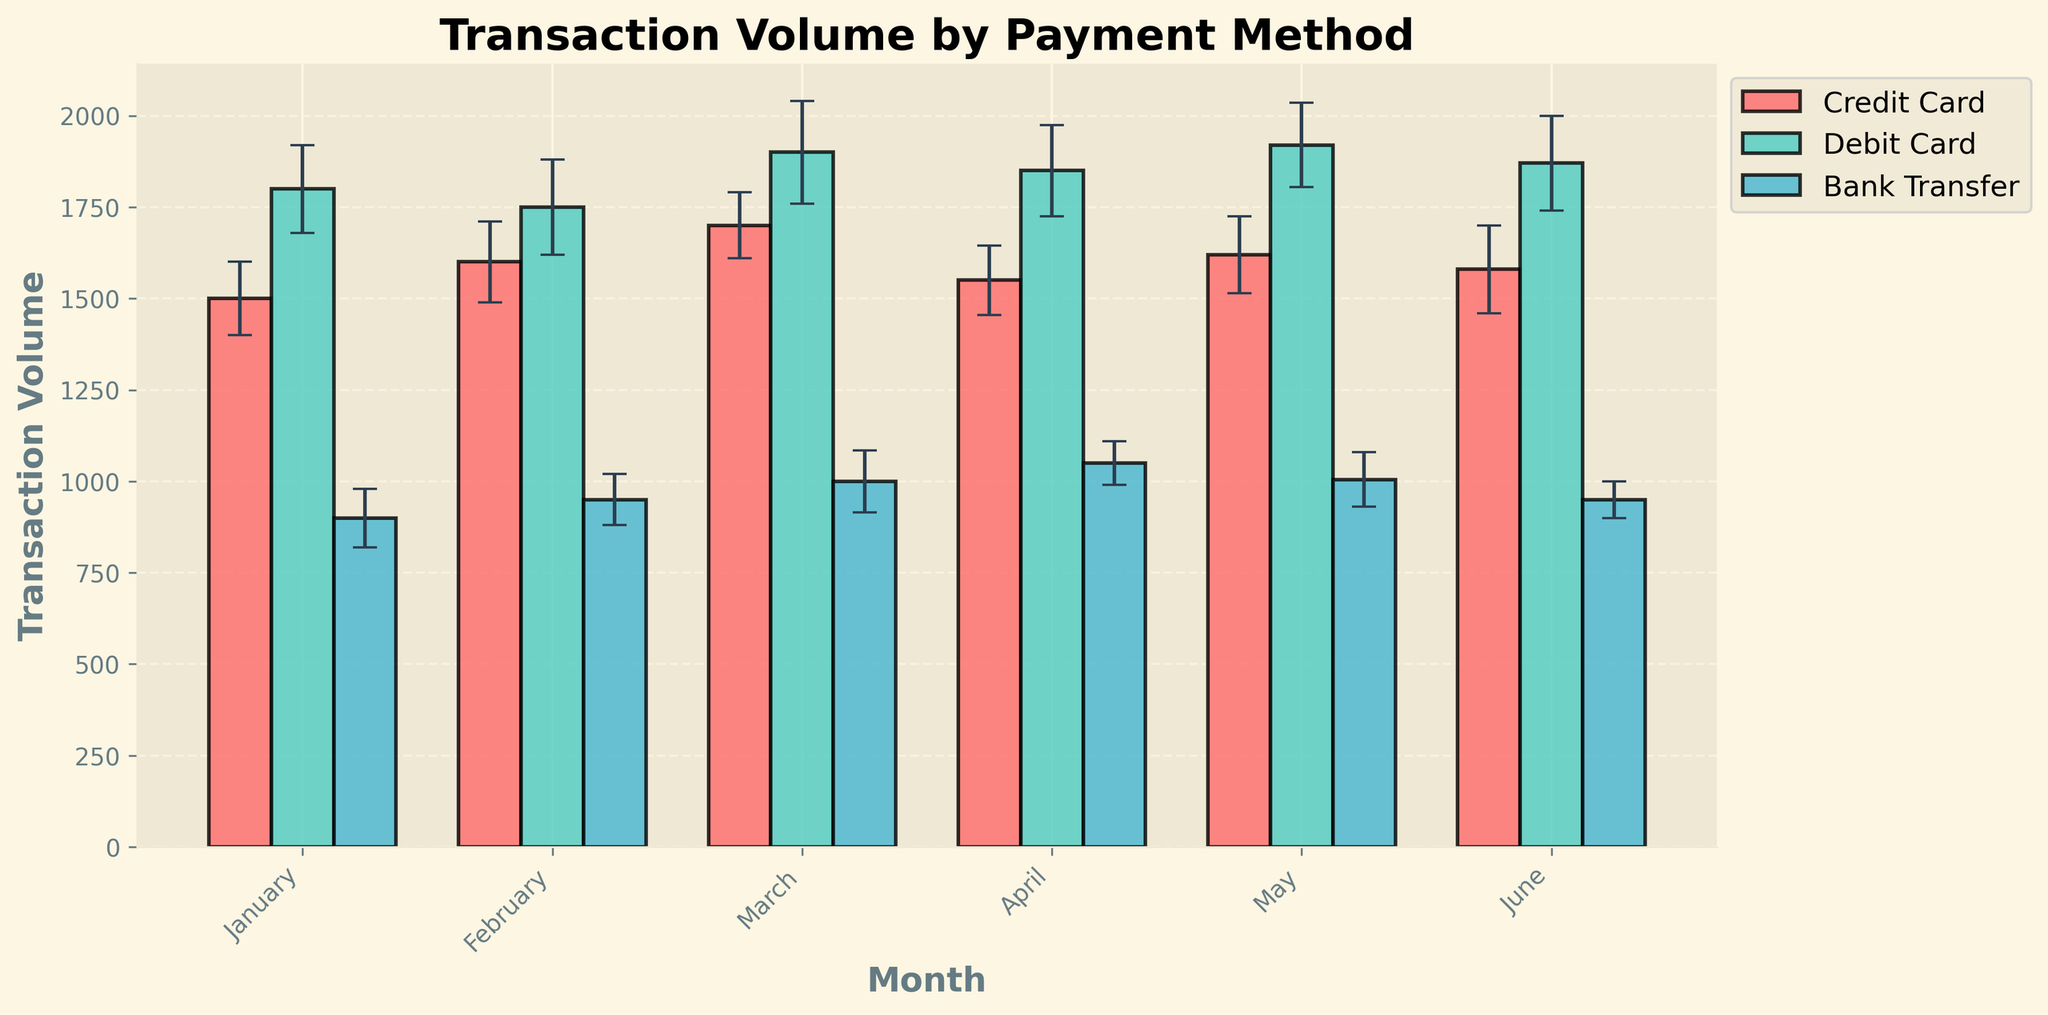What is the title of the figure? The title of the figure is displayed prominently at the top and is a basic element of the plot. It provides a brief description of what the figure is about.
Answer: Transaction Volume by Payment Method Which payment method had the highest transaction volume in March? To find the highest transaction volume for March, look at the bars corresponding to March and compare their heights. The Debit Card bar is the tallest among Credit Card, Debit Card, and Bank Transfer for March.
Answer: Debit Card What is the average transaction volume for Credit Card across all months? First, sum the transaction volumes for Credit Card from January to June (1500 + 1600 + 1700 + 1550 + 1620 + 1580 = 9550). Then, divide by the number of months (6).
Answer: 1591.67 In which month did Bank Transfer have the lowest transaction volume? To find the lowest value, examine the heights of the Bank Transfer bars across all months. The shortest bar corresponds to January.
Answer: January By how much did the Debit Card transaction volume increase from January to June? Calculate the difference in transaction volume for Debit Card between January (1800) and June (1870). Subtract the January value from the June value (1870 - 1800 = 70).
Answer: 70 Which payment method shows the least variation in transaction volume over the months? Least variation can be approximated by comparing the heights of the bars for each payment method over different months. Bank Transfer shows the smallest fluctuations.
Answer: Bank Transfer Which month saw the highest total transaction volume across all payment methods? Sum the transaction volumes for all payment methods for each month and compare. For March: 1700 (Credit Card) + 1900 (Debit Card) + 1000 (Bank Transfer) = 4600, which is the highest.
Answer: March What is the standard error range for Debit Card transactions in February? The standard error range can be found using the error bars. For Debit Card in February, the error is ±130, with a transaction volume of 1750. So, the range is 1750 ± 130 leading to [1620, 1880].
Answer: [1620, 1880] Which payment method generally has the largest error across the months? Reviewing the sizes of the error bars for each payment method, it is observed that Debit Card consistently has larger error bars compared to Credit Card and Bank Transfer.
Answer: Debit Card 